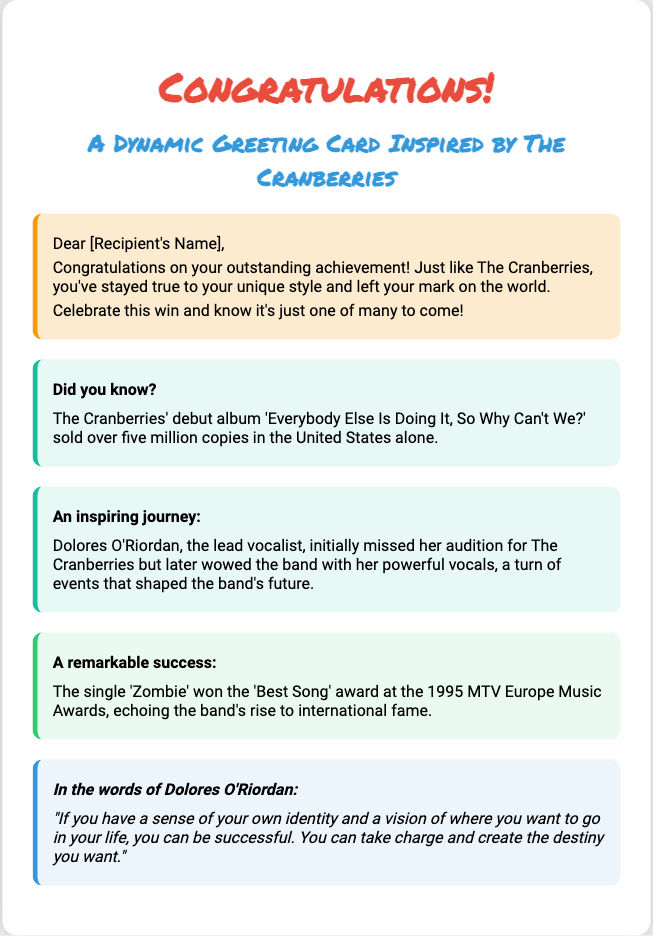What is the title of the greeting card? The title of the greeting card is prominently displayed at the top of the document.
Answer: Congratulations! What color is used for the main title? The color of the main title is specified in the style section of the document.
Answer: #e74c3c What is the name of The Cranberries' debut album? The debut album is mentioned in the fun facts section of the document.
Answer: Everybody Else Is Doing It, So Why Can't We? Who was the lead vocalist of The Cranberries? The lead vocalist is referenced in the text describing the band's journey.
Answer: Dolores O'Riordan What award did the single 'Zombie' win? The information about the award won by the single 'Zombie' is in the success highlight section.
Answer: Best Song According to Dolores O'Riordan, what is essential for success? This essential aspect is quoted in the celebratory quote section.
Answer: Sense of identity What background inspires the design of the greeting card? The background inspiration is stated in the introductory part of the document.
Answer: The Cranberries' album art How many copies did The Cranberries' debut album sell in the United States? This figure is provided in the fun fact section regarding the debut album's success.
Answer: Over five million 